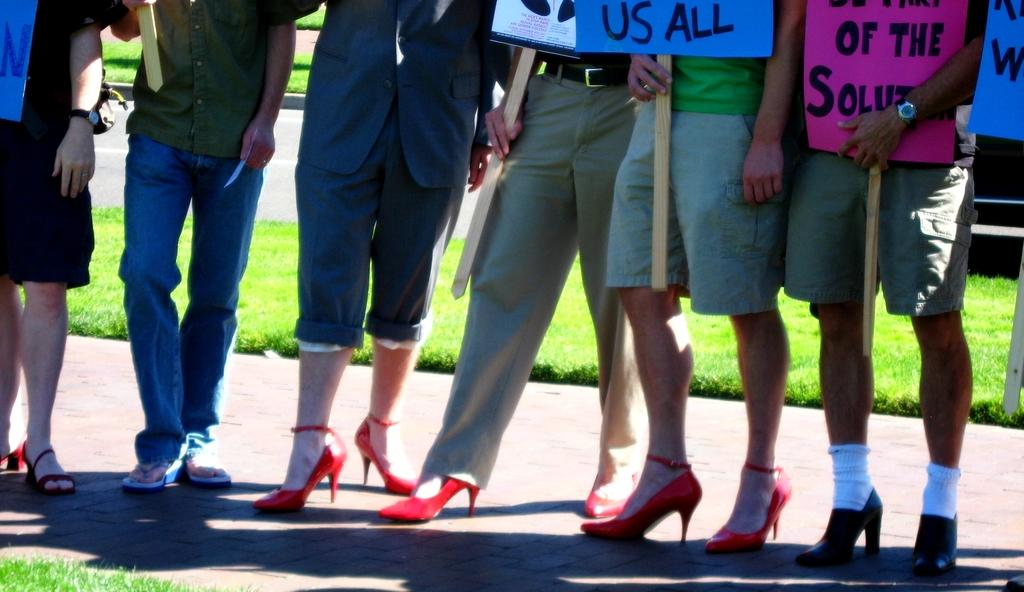What are the people in the image doing? The people in the image are holding cards. Where are the people standing in the image? The people are standing on a road. What type of surface is visible beneath the people's feet? There is a pavement in the image. What can be seen in the background of the image? There is a grass carpet visible in the background. How many ants can be seen crawling on the jar in the image? There is no jar or ants present in the image. What type of connection is established between the people in the image? The image does not show any connections between the people; they are simply holding cards. 